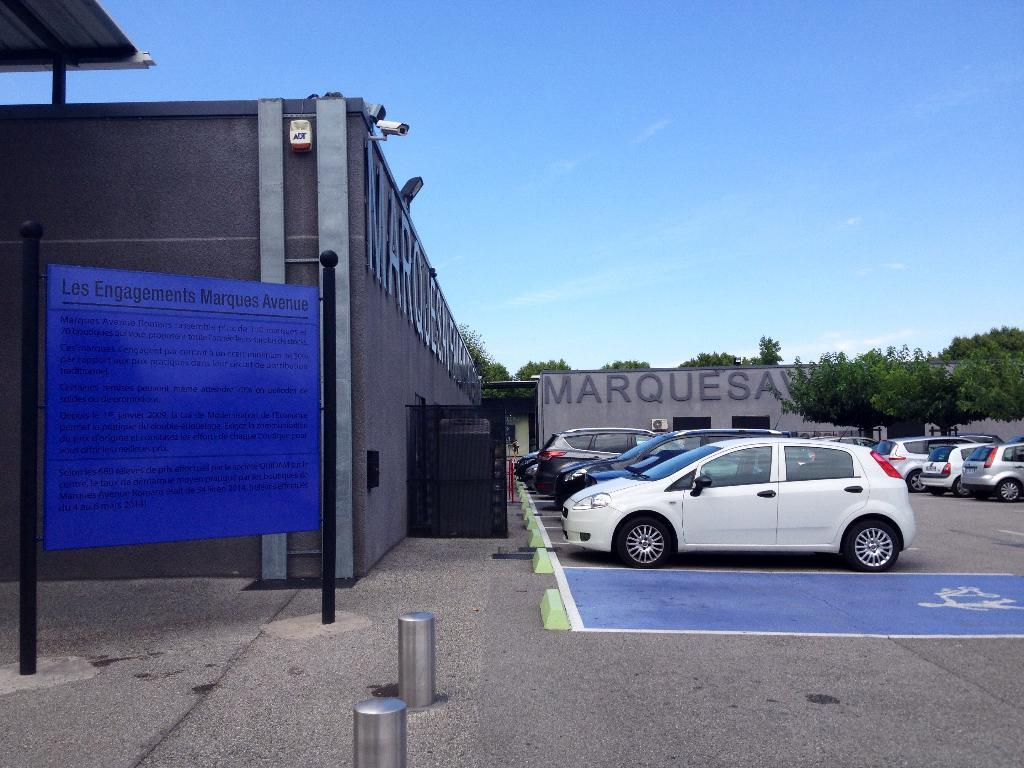What can be seen in the parking lot in the image? There is a group of cars in the parking lot. What is visible in the background of the image? There are buildings, a sign board, poles, trees, and the sky visible in the background. Can you tell me how many people are smiling in the image? There are no people present in the image, so it is not possible to determine how many are smiling. 